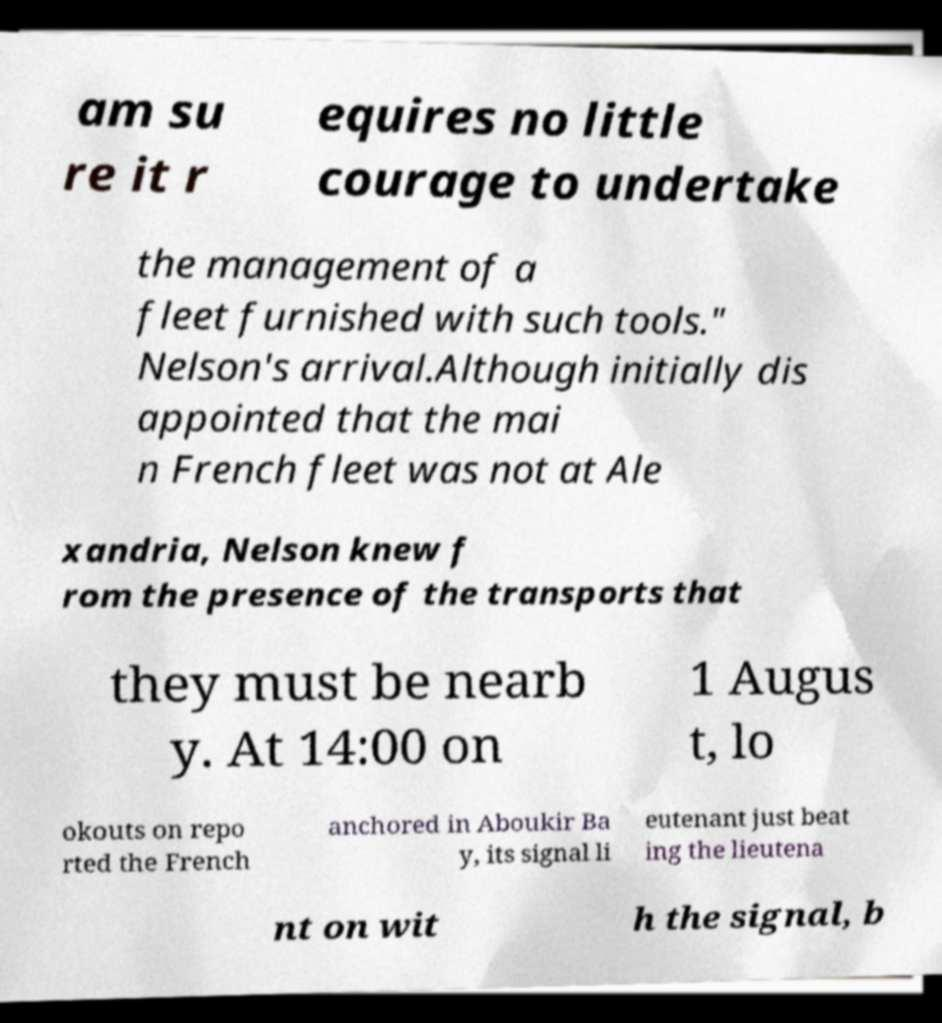Please read and relay the text visible in this image. What does it say? am su re it r equires no little courage to undertake the management of a fleet furnished with such tools." Nelson's arrival.Although initially dis appointed that the mai n French fleet was not at Ale xandria, Nelson knew f rom the presence of the transports that they must be nearb y. At 14:00 on 1 Augus t, lo okouts on repo rted the French anchored in Aboukir Ba y, its signal li eutenant just beat ing the lieutena nt on wit h the signal, b 